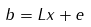Convert formula to latex. <formula><loc_0><loc_0><loc_500><loc_500>b = L x + e</formula> 